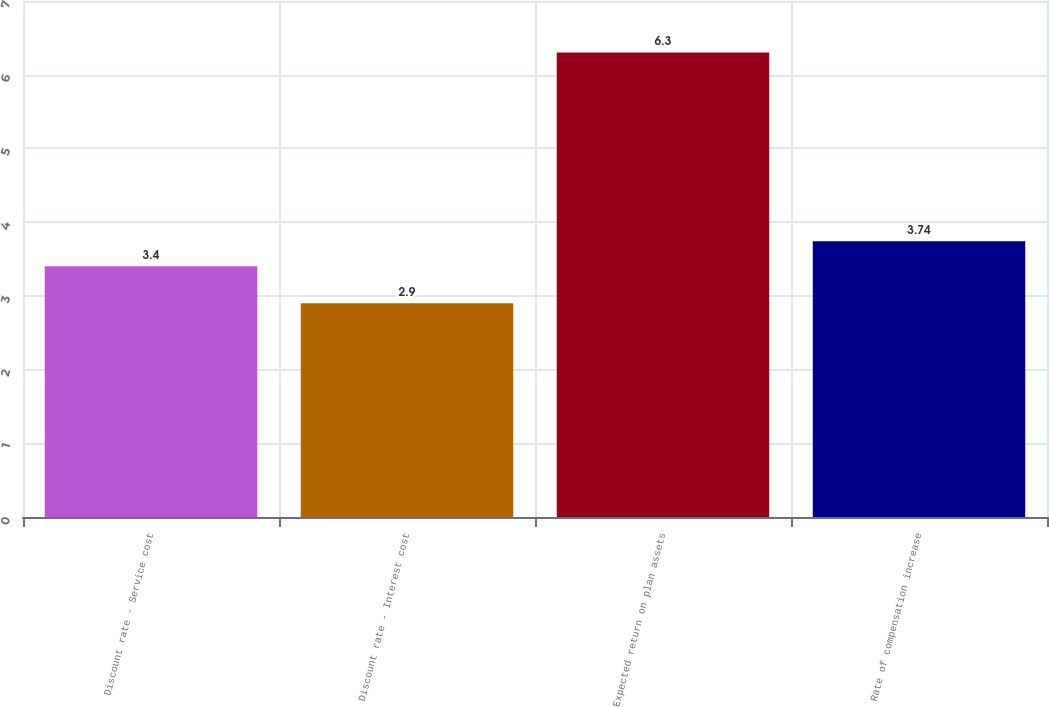<chart> <loc_0><loc_0><loc_500><loc_500><bar_chart><fcel>Discount rate - Service cost<fcel>Discount rate - Interest cost<fcel>Expected return on plan assets<fcel>Rate of compensation increase<nl><fcel>3.4<fcel>2.9<fcel>6.3<fcel>3.74<nl></chart> 